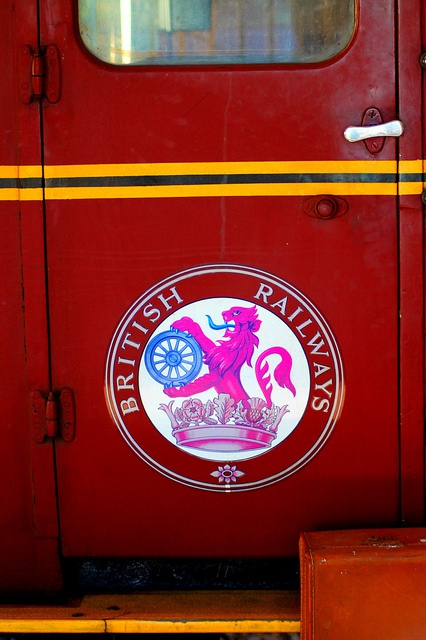Describe the objects in this image and their specific colors. I can see train in maroon, black, and orange tones and suitcase in maroon, brown, and red tones in this image. 